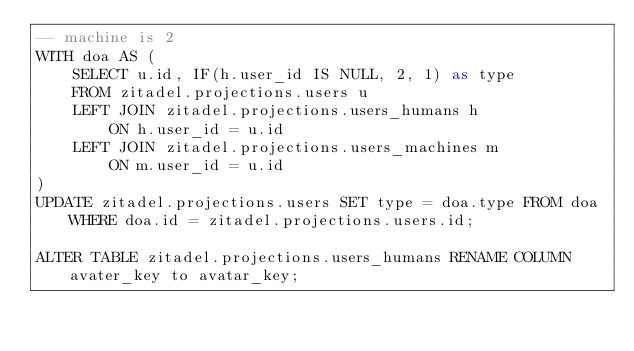Convert code to text. <code><loc_0><loc_0><loc_500><loc_500><_SQL_>-- machine is 2
WITH doa AS (
    SELECT u.id, IF(h.user_id IS NULL, 2, 1) as type
    FROM zitadel.projections.users u 
    LEFT JOIN zitadel.projections.users_humans h
        ON h.user_id = u.id
    LEFT JOIN zitadel.projections.users_machines m
        ON m.user_id = u.id 
)
UPDATE zitadel.projections.users SET type = doa.type FROM doa WHERE doa.id = zitadel.projections.users.id;

ALTER TABLE zitadel.projections.users_humans RENAME COLUMN avater_key to avatar_key;
</code> 